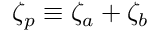Convert formula to latex. <formula><loc_0><loc_0><loc_500><loc_500>\zeta _ { p } \equiv \zeta _ { a } + \zeta _ { b }</formula> 